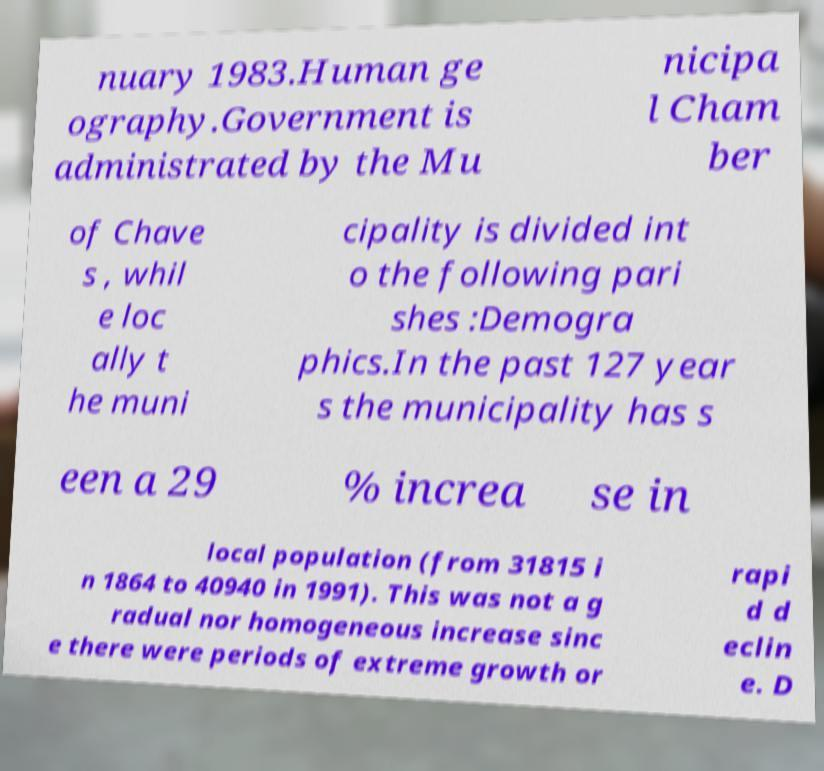Could you extract and type out the text from this image? nuary 1983.Human ge ography.Government is administrated by the Mu nicipa l Cham ber of Chave s , whil e loc ally t he muni cipality is divided int o the following pari shes :Demogra phics.In the past 127 year s the municipality has s een a 29 % increa se in local population (from 31815 i n 1864 to 40940 in 1991). This was not a g radual nor homogeneous increase sinc e there were periods of extreme growth or rapi d d eclin e. D 